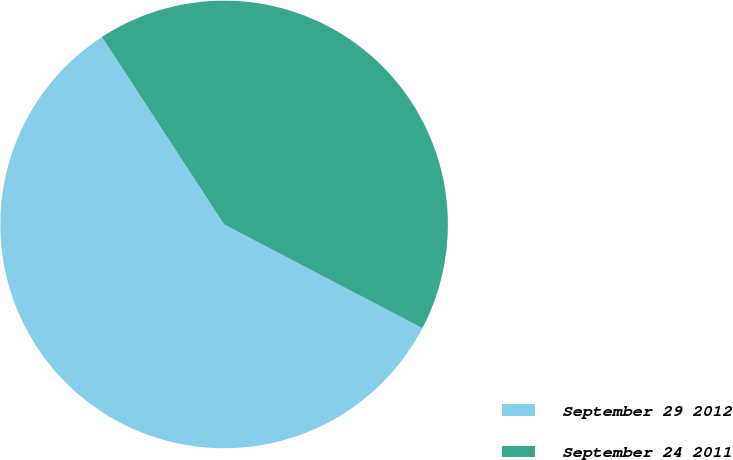Convert chart. <chart><loc_0><loc_0><loc_500><loc_500><pie_chart><fcel>September 29 2012<fcel>September 24 2011<nl><fcel>58.14%<fcel>41.86%<nl></chart> 